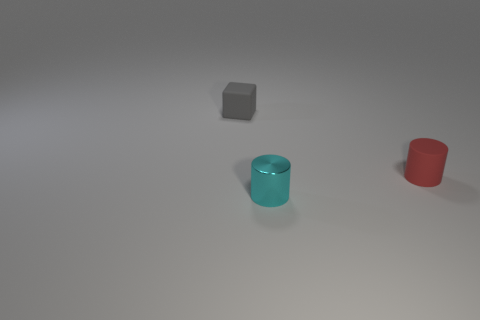There is a rubber thing that is on the left side of the tiny rubber thing in front of the matte object that is on the left side of the cyan metallic cylinder; what is its size?
Your answer should be compact. Small. Is the number of matte things greater than the number of things?
Make the answer very short. No. Do the thing that is left of the tiny shiny cylinder and the tiny object that is in front of the red thing have the same material?
Provide a short and direct response. No. What number of gray matte objects have the same size as the cyan shiny cylinder?
Your answer should be very brief. 1. Is the number of gray matte blocks less than the number of objects?
Your response must be concise. Yes. There is a matte object that is behind the cylinder that is behind the cyan metallic cylinder; what is its shape?
Your answer should be very brief. Cube. There is a shiny thing that is the same size as the red cylinder; what is its shape?
Your response must be concise. Cylinder. Is there another tiny red thing that has the same shape as the small metal thing?
Offer a very short reply. Yes. What material is the tiny cyan thing?
Make the answer very short. Metal. Are there any small matte objects behind the tiny rubber cylinder?
Give a very brief answer. Yes. 